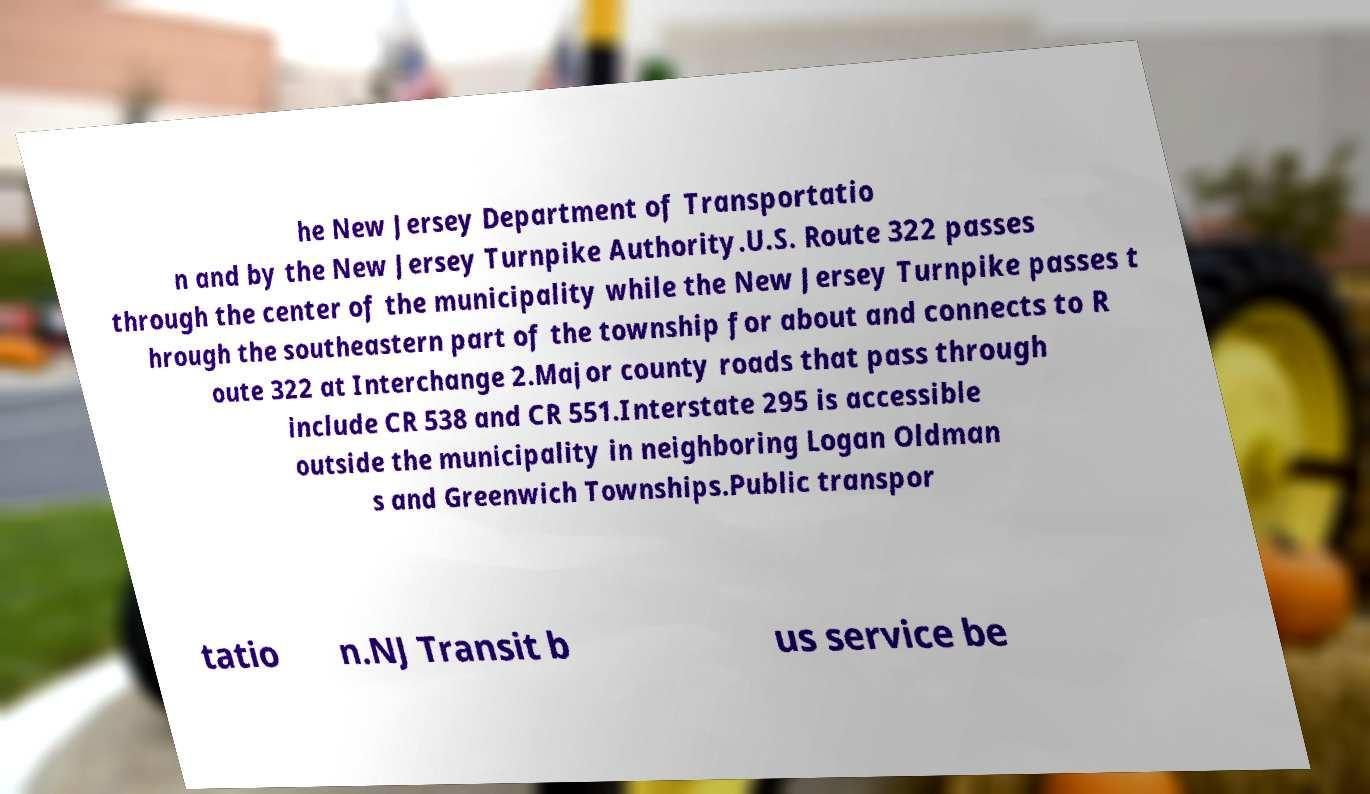Could you extract and type out the text from this image? he New Jersey Department of Transportatio n and by the New Jersey Turnpike Authority.U.S. Route 322 passes through the center of the municipality while the New Jersey Turnpike passes t hrough the southeastern part of the township for about and connects to R oute 322 at Interchange 2.Major county roads that pass through include CR 538 and CR 551.Interstate 295 is accessible outside the municipality in neighboring Logan Oldman s and Greenwich Townships.Public transpor tatio n.NJ Transit b us service be 